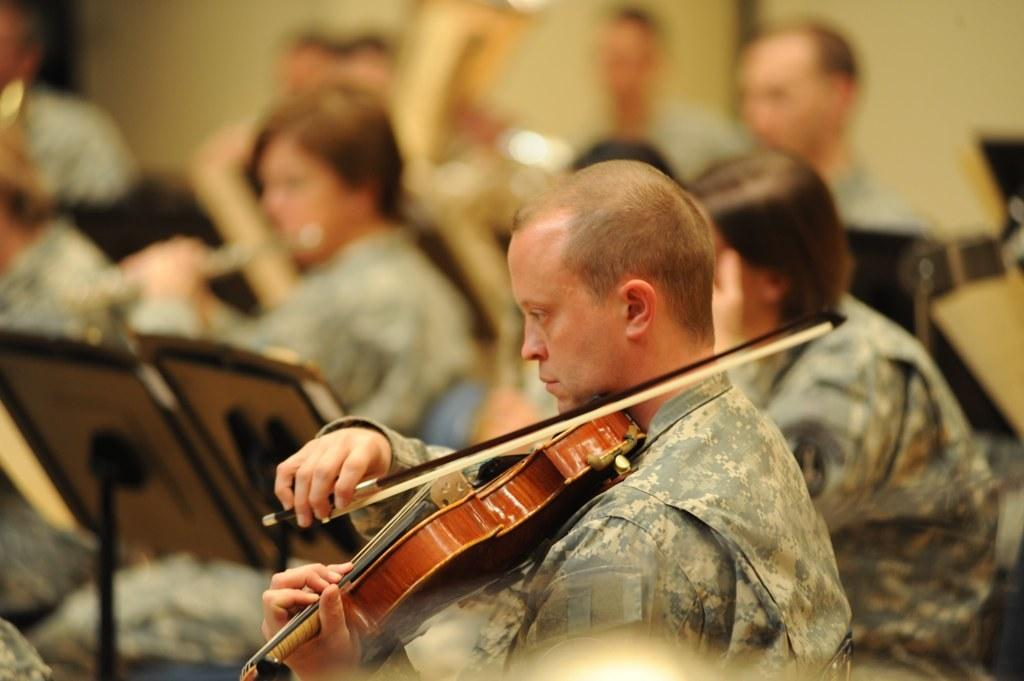How many people are in the image? There are many people in the image. What are the people in the image doing? The people are sitting and playing musical instruments. Can you identify a specific instrument being played by someone in the image? Yes, a man is playing a guitar. What type of birds can be seen flying in the image? There are no birds visible in the image; it features people sitting and playing musical instruments. What month is it in the image? The image does not provide any information about the month; it only shows people playing musical instruments. 